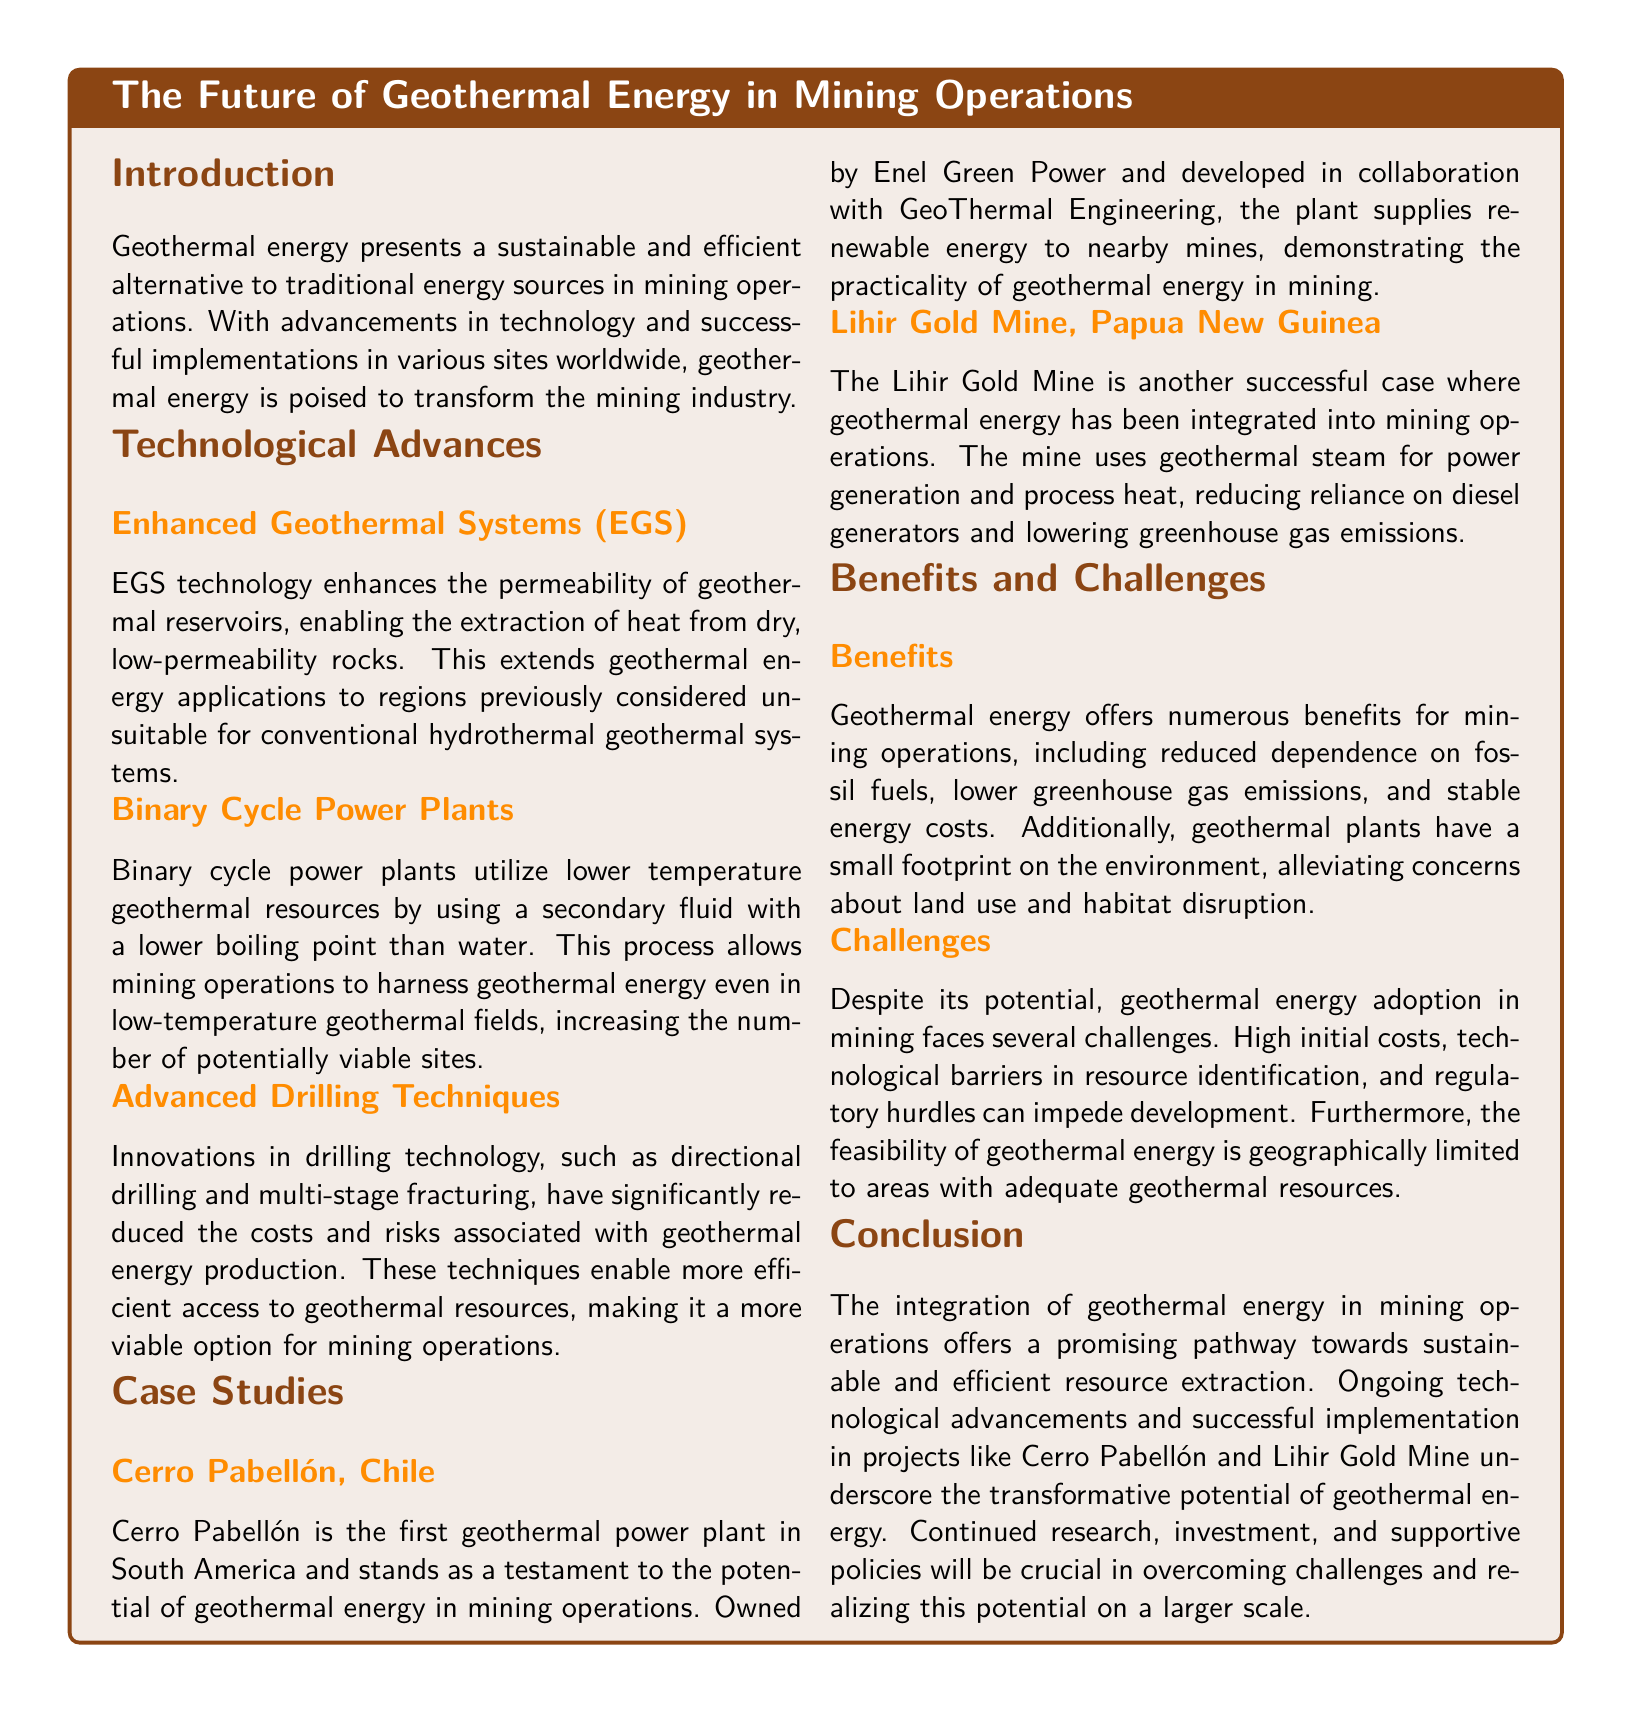What is geothermal energy? Geothermal energy is described as a sustainable and efficient alternative to traditional energy sources in mining operations.
Answer: Sustainable and efficient alternative What are Enhanced Geothermal Systems? Enhanced Geothermal Systems (EGS) enhance the permeability of geothermal reservoirs for better heat extraction from dry, low-permeability rocks.
Answer: EGS What is one benefit of geothermal energy for mining? The document lists reduced dependence on fossil fuels as a benefit of geothermal energy in mining operations.
Answer: Reduced dependence on fossil fuels Where is Cerro Pabellón located? Cerro Pabellón is located in Chile, as mentioned in the case study section of the document.
Answer: Chile What technology reduces costs in geothermal energy production? Advanced drilling techniques are highlighted for significantly reducing costs associated with geothermal energy production.
Answer: Advanced drilling techniques What is a challenge of adopting geothermal energy in mining? High initial costs are cited as one of the challenges faced in the adoption of geothermal energy in mining.
Answer: High initial costs Who owns the Cerro Pabellón geothermal power plant? The document states that Enel Green Power owns Cerro Pabellón.
Answer: Enel Green Power What mining operation uses geothermal steam for power generation? The Lihir Gold Mine uses geothermal steam for both power generation and process heat.
Answer: Lihir Gold Mine How does geothermal energy impact greenhouse gas emissions? The integration of geothermal energy in mining operations is said to reduce greenhouse gas emissions.
Answer: Reduce greenhouse gas emissions 